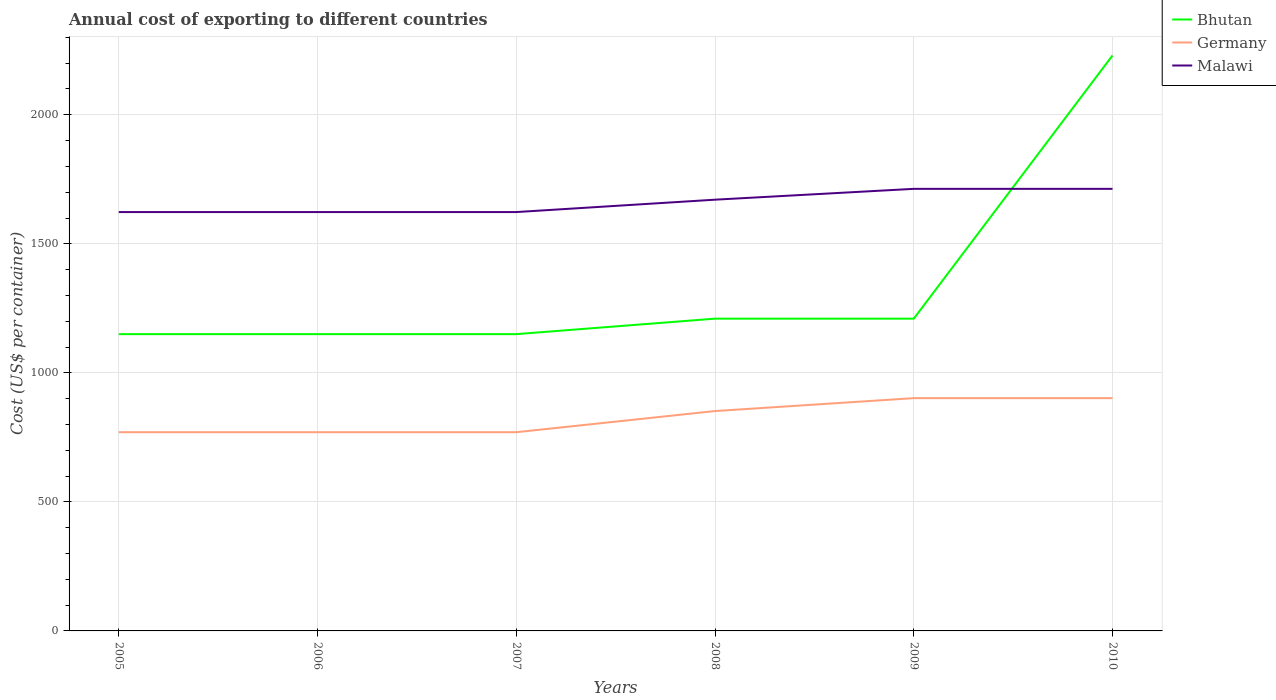Across all years, what is the maximum total annual cost of exporting in Germany?
Ensure brevity in your answer.  770. In which year was the total annual cost of exporting in Bhutan maximum?
Your answer should be compact. 2005. What is the difference between the highest and the second highest total annual cost of exporting in Malawi?
Your response must be concise. 90. What is the difference between two consecutive major ticks on the Y-axis?
Ensure brevity in your answer.  500. Does the graph contain any zero values?
Provide a short and direct response. No. Does the graph contain grids?
Make the answer very short. Yes. Where does the legend appear in the graph?
Provide a succinct answer. Top right. How many legend labels are there?
Provide a short and direct response. 3. What is the title of the graph?
Give a very brief answer. Annual cost of exporting to different countries. Does "Bermuda" appear as one of the legend labels in the graph?
Provide a short and direct response. No. What is the label or title of the X-axis?
Offer a very short reply. Years. What is the label or title of the Y-axis?
Your answer should be compact. Cost (US$ per container). What is the Cost (US$ per container) in Bhutan in 2005?
Offer a very short reply. 1150. What is the Cost (US$ per container) in Germany in 2005?
Provide a succinct answer. 770. What is the Cost (US$ per container) in Malawi in 2005?
Ensure brevity in your answer.  1623. What is the Cost (US$ per container) of Bhutan in 2006?
Ensure brevity in your answer.  1150. What is the Cost (US$ per container) in Germany in 2006?
Your answer should be compact. 770. What is the Cost (US$ per container) in Malawi in 2006?
Your answer should be compact. 1623. What is the Cost (US$ per container) in Bhutan in 2007?
Offer a very short reply. 1150. What is the Cost (US$ per container) of Germany in 2007?
Ensure brevity in your answer.  770. What is the Cost (US$ per container) of Malawi in 2007?
Offer a very short reply. 1623. What is the Cost (US$ per container) of Bhutan in 2008?
Provide a succinct answer. 1210. What is the Cost (US$ per container) in Germany in 2008?
Offer a very short reply. 852. What is the Cost (US$ per container) in Malawi in 2008?
Provide a succinct answer. 1671. What is the Cost (US$ per container) of Bhutan in 2009?
Keep it short and to the point. 1210. What is the Cost (US$ per container) in Germany in 2009?
Your answer should be compact. 902. What is the Cost (US$ per container) in Malawi in 2009?
Give a very brief answer. 1713. What is the Cost (US$ per container) of Bhutan in 2010?
Offer a very short reply. 2230. What is the Cost (US$ per container) of Germany in 2010?
Keep it short and to the point. 902. What is the Cost (US$ per container) in Malawi in 2010?
Give a very brief answer. 1713. Across all years, what is the maximum Cost (US$ per container) of Bhutan?
Give a very brief answer. 2230. Across all years, what is the maximum Cost (US$ per container) in Germany?
Provide a succinct answer. 902. Across all years, what is the maximum Cost (US$ per container) of Malawi?
Your answer should be compact. 1713. Across all years, what is the minimum Cost (US$ per container) of Bhutan?
Offer a very short reply. 1150. Across all years, what is the minimum Cost (US$ per container) in Germany?
Your response must be concise. 770. Across all years, what is the minimum Cost (US$ per container) of Malawi?
Ensure brevity in your answer.  1623. What is the total Cost (US$ per container) in Bhutan in the graph?
Your response must be concise. 8100. What is the total Cost (US$ per container) of Germany in the graph?
Keep it short and to the point. 4966. What is the total Cost (US$ per container) of Malawi in the graph?
Offer a terse response. 9966. What is the difference between the Cost (US$ per container) in Bhutan in 2005 and that in 2006?
Your answer should be very brief. 0. What is the difference between the Cost (US$ per container) of Germany in 2005 and that in 2006?
Offer a terse response. 0. What is the difference between the Cost (US$ per container) of Bhutan in 2005 and that in 2007?
Offer a terse response. 0. What is the difference between the Cost (US$ per container) in Malawi in 2005 and that in 2007?
Keep it short and to the point. 0. What is the difference between the Cost (US$ per container) in Bhutan in 2005 and that in 2008?
Provide a succinct answer. -60. What is the difference between the Cost (US$ per container) in Germany in 2005 and that in 2008?
Give a very brief answer. -82. What is the difference between the Cost (US$ per container) in Malawi in 2005 and that in 2008?
Make the answer very short. -48. What is the difference between the Cost (US$ per container) in Bhutan in 2005 and that in 2009?
Offer a terse response. -60. What is the difference between the Cost (US$ per container) of Germany in 2005 and that in 2009?
Your response must be concise. -132. What is the difference between the Cost (US$ per container) of Malawi in 2005 and that in 2009?
Give a very brief answer. -90. What is the difference between the Cost (US$ per container) in Bhutan in 2005 and that in 2010?
Offer a very short reply. -1080. What is the difference between the Cost (US$ per container) of Germany in 2005 and that in 2010?
Offer a terse response. -132. What is the difference between the Cost (US$ per container) of Malawi in 2005 and that in 2010?
Ensure brevity in your answer.  -90. What is the difference between the Cost (US$ per container) in Bhutan in 2006 and that in 2007?
Your response must be concise. 0. What is the difference between the Cost (US$ per container) in Germany in 2006 and that in 2007?
Keep it short and to the point. 0. What is the difference between the Cost (US$ per container) of Malawi in 2006 and that in 2007?
Make the answer very short. 0. What is the difference between the Cost (US$ per container) of Bhutan in 2006 and that in 2008?
Give a very brief answer. -60. What is the difference between the Cost (US$ per container) in Germany in 2006 and that in 2008?
Give a very brief answer. -82. What is the difference between the Cost (US$ per container) in Malawi in 2006 and that in 2008?
Provide a succinct answer. -48. What is the difference between the Cost (US$ per container) of Bhutan in 2006 and that in 2009?
Make the answer very short. -60. What is the difference between the Cost (US$ per container) of Germany in 2006 and that in 2009?
Your answer should be very brief. -132. What is the difference between the Cost (US$ per container) of Malawi in 2006 and that in 2009?
Provide a short and direct response. -90. What is the difference between the Cost (US$ per container) in Bhutan in 2006 and that in 2010?
Make the answer very short. -1080. What is the difference between the Cost (US$ per container) of Germany in 2006 and that in 2010?
Provide a succinct answer. -132. What is the difference between the Cost (US$ per container) of Malawi in 2006 and that in 2010?
Your answer should be compact. -90. What is the difference between the Cost (US$ per container) of Bhutan in 2007 and that in 2008?
Keep it short and to the point. -60. What is the difference between the Cost (US$ per container) in Germany in 2007 and that in 2008?
Ensure brevity in your answer.  -82. What is the difference between the Cost (US$ per container) of Malawi in 2007 and that in 2008?
Offer a terse response. -48. What is the difference between the Cost (US$ per container) of Bhutan in 2007 and that in 2009?
Your answer should be very brief. -60. What is the difference between the Cost (US$ per container) of Germany in 2007 and that in 2009?
Keep it short and to the point. -132. What is the difference between the Cost (US$ per container) in Malawi in 2007 and that in 2009?
Your answer should be very brief. -90. What is the difference between the Cost (US$ per container) in Bhutan in 2007 and that in 2010?
Offer a very short reply. -1080. What is the difference between the Cost (US$ per container) in Germany in 2007 and that in 2010?
Provide a succinct answer. -132. What is the difference between the Cost (US$ per container) in Malawi in 2007 and that in 2010?
Provide a succinct answer. -90. What is the difference between the Cost (US$ per container) of Germany in 2008 and that in 2009?
Ensure brevity in your answer.  -50. What is the difference between the Cost (US$ per container) of Malawi in 2008 and that in 2009?
Your response must be concise. -42. What is the difference between the Cost (US$ per container) in Bhutan in 2008 and that in 2010?
Give a very brief answer. -1020. What is the difference between the Cost (US$ per container) of Germany in 2008 and that in 2010?
Offer a terse response. -50. What is the difference between the Cost (US$ per container) in Malawi in 2008 and that in 2010?
Offer a very short reply. -42. What is the difference between the Cost (US$ per container) of Bhutan in 2009 and that in 2010?
Make the answer very short. -1020. What is the difference between the Cost (US$ per container) in Malawi in 2009 and that in 2010?
Ensure brevity in your answer.  0. What is the difference between the Cost (US$ per container) of Bhutan in 2005 and the Cost (US$ per container) of Germany in 2006?
Make the answer very short. 380. What is the difference between the Cost (US$ per container) in Bhutan in 2005 and the Cost (US$ per container) in Malawi in 2006?
Your answer should be very brief. -473. What is the difference between the Cost (US$ per container) in Germany in 2005 and the Cost (US$ per container) in Malawi in 2006?
Ensure brevity in your answer.  -853. What is the difference between the Cost (US$ per container) of Bhutan in 2005 and the Cost (US$ per container) of Germany in 2007?
Make the answer very short. 380. What is the difference between the Cost (US$ per container) of Bhutan in 2005 and the Cost (US$ per container) of Malawi in 2007?
Provide a succinct answer. -473. What is the difference between the Cost (US$ per container) of Germany in 2005 and the Cost (US$ per container) of Malawi in 2007?
Offer a very short reply. -853. What is the difference between the Cost (US$ per container) in Bhutan in 2005 and the Cost (US$ per container) in Germany in 2008?
Give a very brief answer. 298. What is the difference between the Cost (US$ per container) in Bhutan in 2005 and the Cost (US$ per container) in Malawi in 2008?
Provide a succinct answer. -521. What is the difference between the Cost (US$ per container) in Germany in 2005 and the Cost (US$ per container) in Malawi in 2008?
Ensure brevity in your answer.  -901. What is the difference between the Cost (US$ per container) of Bhutan in 2005 and the Cost (US$ per container) of Germany in 2009?
Give a very brief answer. 248. What is the difference between the Cost (US$ per container) of Bhutan in 2005 and the Cost (US$ per container) of Malawi in 2009?
Ensure brevity in your answer.  -563. What is the difference between the Cost (US$ per container) of Germany in 2005 and the Cost (US$ per container) of Malawi in 2009?
Provide a succinct answer. -943. What is the difference between the Cost (US$ per container) in Bhutan in 2005 and the Cost (US$ per container) in Germany in 2010?
Provide a succinct answer. 248. What is the difference between the Cost (US$ per container) of Bhutan in 2005 and the Cost (US$ per container) of Malawi in 2010?
Offer a very short reply. -563. What is the difference between the Cost (US$ per container) in Germany in 2005 and the Cost (US$ per container) in Malawi in 2010?
Provide a short and direct response. -943. What is the difference between the Cost (US$ per container) in Bhutan in 2006 and the Cost (US$ per container) in Germany in 2007?
Provide a succinct answer. 380. What is the difference between the Cost (US$ per container) of Bhutan in 2006 and the Cost (US$ per container) of Malawi in 2007?
Offer a very short reply. -473. What is the difference between the Cost (US$ per container) in Germany in 2006 and the Cost (US$ per container) in Malawi in 2007?
Your response must be concise. -853. What is the difference between the Cost (US$ per container) of Bhutan in 2006 and the Cost (US$ per container) of Germany in 2008?
Provide a succinct answer. 298. What is the difference between the Cost (US$ per container) in Bhutan in 2006 and the Cost (US$ per container) in Malawi in 2008?
Give a very brief answer. -521. What is the difference between the Cost (US$ per container) of Germany in 2006 and the Cost (US$ per container) of Malawi in 2008?
Ensure brevity in your answer.  -901. What is the difference between the Cost (US$ per container) of Bhutan in 2006 and the Cost (US$ per container) of Germany in 2009?
Ensure brevity in your answer.  248. What is the difference between the Cost (US$ per container) in Bhutan in 2006 and the Cost (US$ per container) in Malawi in 2009?
Your answer should be compact. -563. What is the difference between the Cost (US$ per container) of Germany in 2006 and the Cost (US$ per container) of Malawi in 2009?
Your answer should be very brief. -943. What is the difference between the Cost (US$ per container) in Bhutan in 2006 and the Cost (US$ per container) in Germany in 2010?
Keep it short and to the point. 248. What is the difference between the Cost (US$ per container) of Bhutan in 2006 and the Cost (US$ per container) of Malawi in 2010?
Provide a short and direct response. -563. What is the difference between the Cost (US$ per container) in Germany in 2006 and the Cost (US$ per container) in Malawi in 2010?
Your response must be concise. -943. What is the difference between the Cost (US$ per container) in Bhutan in 2007 and the Cost (US$ per container) in Germany in 2008?
Your response must be concise. 298. What is the difference between the Cost (US$ per container) of Bhutan in 2007 and the Cost (US$ per container) of Malawi in 2008?
Your answer should be very brief. -521. What is the difference between the Cost (US$ per container) of Germany in 2007 and the Cost (US$ per container) of Malawi in 2008?
Provide a succinct answer. -901. What is the difference between the Cost (US$ per container) in Bhutan in 2007 and the Cost (US$ per container) in Germany in 2009?
Keep it short and to the point. 248. What is the difference between the Cost (US$ per container) of Bhutan in 2007 and the Cost (US$ per container) of Malawi in 2009?
Offer a terse response. -563. What is the difference between the Cost (US$ per container) of Germany in 2007 and the Cost (US$ per container) of Malawi in 2009?
Offer a terse response. -943. What is the difference between the Cost (US$ per container) in Bhutan in 2007 and the Cost (US$ per container) in Germany in 2010?
Keep it short and to the point. 248. What is the difference between the Cost (US$ per container) of Bhutan in 2007 and the Cost (US$ per container) of Malawi in 2010?
Ensure brevity in your answer.  -563. What is the difference between the Cost (US$ per container) in Germany in 2007 and the Cost (US$ per container) in Malawi in 2010?
Provide a short and direct response. -943. What is the difference between the Cost (US$ per container) in Bhutan in 2008 and the Cost (US$ per container) in Germany in 2009?
Give a very brief answer. 308. What is the difference between the Cost (US$ per container) of Bhutan in 2008 and the Cost (US$ per container) of Malawi in 2009?
Your answer should be very brief. -503. What is the difference between the Cost (US$ per container) of Germany in 2008 and the Cost (US$ per container) of Malawi in 2009?
Provide a succinct answer. -861. What is the difference between the Cost (US$ per container) of Bhutan in 2008 and the Cost (US$ per container) of Germany in 2010?
Keep it short and to the point. 308. What is the difference between the Cost (US$ per container) of Bhutan in 2008 and the Cost (US$ per container) of Malawi in 2010?
Offer a terse response. -503. What is the difference between the Cost (US$ per container) of Germany in 2008 and the Cost (US$ per container) of Malawi in 2010?
Provide a succinct answer. -861. What is the difference between the Cost (US$ per container) of Bhutan in 2009 and the Cost (US$ per container) of Germany in 2010?
Offer a terse response. 308. What is the difference between the Cost (US$ per container) in Bhutan in 2009 and the Cost (US$ per container) in Malawi in 2010?
Provide a short and direct response. -503. What is the difference between the Cost (US$ per container) in Germany in 2009 and the Cost (US$ per container) in Malawi in 2010?
Offer a terse response. -811. What is the average Cost (US$ per container) in Bhutan per year?
Offer a very short reply. 1350. What is the average Cost (US$ per container) in Germany per year?
Make the answer very short. 827.67. What is the average Cost (US$ per container) of Malawi per year?
Offer a very short reply. 1661. In the year 2005, what is the difference between the Cost (US$ per container) of Bhutan and Cost (US$ per container) of Germany?
Keep it short and to the point. 380. In the year 2005, what is the difference between the Cost (US$ per container) in Bhutan and Cost (US$ per container) in Malawi?
Provide a short and direct response. -473. In the year 2005, what is the difference between the Cost (US$ per container) of Germany and Cost (US$ per container) of Malawi?
Provide a short and direct response. -853. In the year 2006, what is the difference between the Cost (US$ per container) in Bhutan and Cost (US$ per container) in Germany?
Give a very brief answer. 380. In the year 2006, what is the difference between the Cost (US$ per container) of Bhutan and Cost (US$ per container) of Malawi?
Offer a terse response. -473. In the year 2006, what is the difference between the Cost (US$ per container) in Germany and Cost (US$ per container) in Malawi?
Keep it short and to the point. -853. In the year 2007, what is the difference between the Cost (US$ per container) in Bhutan and Cost (US$ per container) in Germany?
Your response must be concise. 380. In the year 2007, what is the difference between the Cost (US$ per container) in Bhutan and Cost (US$ per container) in Malawi?
Make the answer very short. -473. In the year 2007, what is the difference between the Cost (US$ per container) of Germany and Cost (US$ per container) of Malawi?
Your answer should be compact. -853. In the year 2008, what is the difference between the Cost (US$ per container) of Bhutan and Cost (US$ per container) of Germany?
Your answer should be compact. 358. In the year 2008, what is the difference between the Cost (US$ per container) of Bhutan and Cost (US$ per container) of Malawi?
Your response must be concise. -461. In the year 2008, what is the difference between the Cost (US$ per container) of Germany and Cost (US$ per container) of Malawi?
Offer a very short reply. -819. In the year 2009, what is the difference between the Cost (US$ per container) of Bhutan and Cost (US$ per container) of Germany?
Give a very brief answer. 308. In the year 2009, what is the difference between the Cost (US$ per container) in Bhutan and Cost (US$ per container) in Malawi?
Your response must be concise. -503. In the year 2009, what is the difference between the Cost (US$ per container) of Germany and Cost (US$ per container) of Malawi?
Provide a succinct answer. -811. In the year 2010, what is the difference between the Cost (US$ per container) in Bhutan and Cost (US$ per container) in Germany?
Ensure brevity in your answer.  1328. In the year 2010, what is the difference between the Cost (US$ per container) in Bhutan and Cost (US$ per container) in Malawi?
Provide a short and direct response. 517. In the year 2010, what is the difference between the Cost (US$ per container) in Germany and Cost (US$ per container) in Malawi?
Your response must be concise. -811. What is the ratio of the Cost (US$ per container) of Bhutan in 2005 to that in 2006?
Ensure brevity in your answer.  1. What is the ratio of the Cost (US$ per container) of Malawi in 2005 to that in 2006?
Provide a succinct answer. 1. What is the ratio of the Cost (US$ per container) of Bhutan in 2005 to that in 2007?
Give a very brief answer. 1. What is the ratio of the Cost (US$ per container) in Malawi in 2005 to that in 2007?
Provide a short and direct response. 1. What is the ratio of the Cost (US$ per container) in Bhutan in 2005 to that in 2008?
Your answer should be very brief. 0.95. What is the ratio of the Cost (US$ per container) in Germany in 2005 to that in 2008?
Offer a terse response. 0.9. What is the ratio of the Cost (US$ per container) in Malawi in 2005 to that in 2008?
Offer a very short reply. 0.97. What is the ratio of the Cost (US$ per container) of Bhutan in 2005 to that in 2009?
Offer a terse response. 0.95. What is the ratio of the Cost (US$ per container) in Germany in 2005 to that in 2009?
Provide a short and direct response. 0.85. What is the ratio of the Cost (US$ per container) of Malawi in 2005 to that in 2009?
Your response must be concise. 0.95. What is the ratio of the Cost (US$ per container) in Bhutan in 2005 to that in 2010?
Your answer should be very brief. 0.52. What is the ratio of the Cost (US$ per container) of Germany in 2005 to that in 2010?
Keep it short and to the point. 0.85. What is the ratio of the Cost (US$ per container) of Malawi in 2005 to that in 2010?
Provide a short and direct response. 0.95. What is the ratio of the Cost (US$ per container) in Malawi in 2006 to that in 2007?
Make the answer very short. 1. What is the ratio of the Cost (US$ per container) in Bhutan in 2006 to that in 2008?
Provide a succinct answer. 0.95. What is the ratio of the Cost (US$ per container) in Germany in 2006 to that in 2008?
Provide a short and direct response. 0.9. What is the ratio of the Cost (US$ per container) of Malawi in 2006 to that in 2008?
Offer a very short reply. 0.97. What is the ratio of the Cost (US$ per container) of Bhutan in 2006 to that in 2009?
Provide a short and direct response. 0.95. What is the ratio of the Cost (US$ per container) of Germany in 2006 to that in 2009?
Give a very brief answer. 0.85. What is the ratio of the Cost (US$ per container) in Malawi in 2006 to that in 2009?
Your answer should be compact. 0.95. What is the ratio of the Cost (US$ per container) in Bhutan in 2006 to that in 2010?
Provide a short and direct response. 0.52. What is the ratio of the Cost (US$ per container) of Germany in 2006 to that in 2010?
Ensure brevity in your answer.  0.85. What is the ratio of the Cost (US$ per container) in Malawi in 2006 to that in 2010?
Your answer should be compact. 0.95. What is the ratio of the Cost (US$ per container) in Bhutan in 2007 to that in 2008?
Provide a short and direct response. 0.95. What is the ratio of the Cost (US$ per container) of Germany in 2007 to that in 2008?
Provide a succinct answer. 0.9. What is the ratio of the Cost (US$ per container) in Malawi in 2007 to that in 2008?
Give a very brief answer. 0.97. What is the ratio of the Cost (US$ per container) of Bhutan in 2007 to that in 2009?
Keep it short and to the point. 0.95. What is the ratio of the Cost (US$ per container) in Germany in 2007 to that in 2009?
Provide a succinct answer. 0.85. What is the ratio of the Cost (US$ per container) of Malawi in 2007 to that in 2009?
Keep it short and to the point. 0.95. What is the ratio of the Cost (US$ per container) of Bhutan in 2007 to that in 2010?
Provide a succinct answer. 0.52. What is the ratio of the Cost (US$ per container) of Germany in 2007 to that in 2010?
Provide a succinct answer. 0.85. What is the ratio of the Cost (US$ per container) of Malawi in 2007 to that in 2010?
Your answer should be compact. 0.95. What is the ratio of the Cost (US$ per container) in Bhutan in 2008 to that in 2009?
Ensure brevity in your answer.  1. What is the ratio of the Cost (US$ per container) in Germany in 2008 to that in 2009?
Offer a terse response. 0.94. What is the ratio of the Cost (US$ per container) in Malawi in 2008 to that in 2009?
Provide a succinct answer. 0.98. What is the ratio of the Cost (US$ per container) in Bhutan in 2008 to that in 2010?
Make the answer very short. 0.54. What is the ratio of the Cost (US$ per container) of Germany in 2008 to that in 2010?
Ensure brevity in your answer.  0.94. What is the ratio of the Cost (US$ per container) in Malawi in 2008 to that in 2010?
Provide a succinct answer. 0.98. What is the ratio of the Cost (US$ per container) in Bhutan in 2009 to that in 2010?
Offer a terse response. 0.54. What is the ratio of the Cost (US$ per container) in Germany in 2009 to that in 2010?
Your answer should be compact. 1. What is the ratio of the Cost (US$ per container) in Malawi in 2009 to that in 2010?
Make the answer very short. 1. What is the difference between the highest and the second highest Cost (US$ per container) of Bhutan?
Give a very brief answer. 1020. What is the difference between the highest and the second highest Cost (US$ per container) of Germany?
Make the answer very short. 0. What is the difference between the highest and the lowest Cost (US$ per container) in Bhutan?
Your response must be concise. 1080. What is the difference between the highest and the lowest Cost (US$ per container) in Germany?
Ensure brevity in your answer.  132. What is the difference between the highest and the lowest Cost (US$ per container) in Malawi?
Provide a short and direct response. 90. 